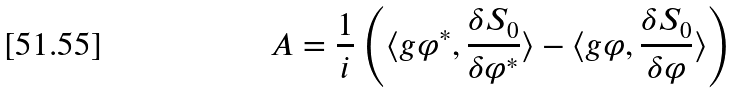Convert formula to latex. <formula><loc_0><loc_0><loc_500><loc_500>A = \frac { 1 } { i } \left ( \langle g \varphi ^ { * } , \frac { \delta S _ { 0 } } { \delta \varphi ^ { * } } \rangle - \langle g \varphi , \frac { \delta S _ { 0 } } { \delta \varphi } \rangle \right )</formula> 